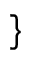<formula> <loc_0><loc_0><loc_500><loc_500>\}</formula> 